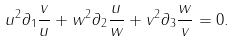<formula> <loc_0><loc_0><loc_500><loc_500>u ^ { 2 } \partial _ { 1 } \frac { v } { u } + w ^ { 2 } \partial _ { 2 } \frac { u } { w } + v ^ { 2 } \partial _ { 3 } \frac { w } { v } = 0 .</formula> 